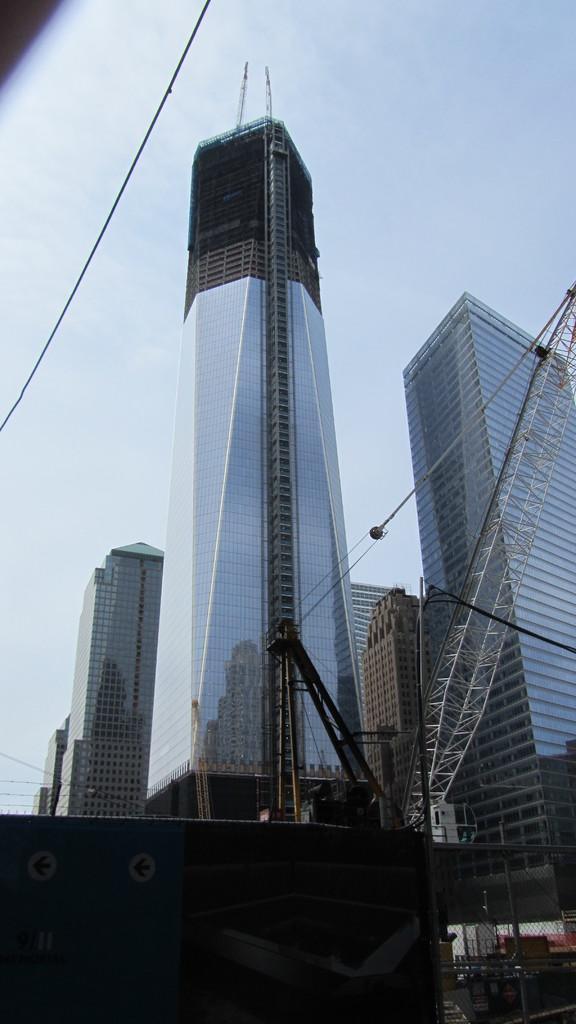Please provide a concise description of this image. In the foreground of this image, at the bottom, there is a shelter and fencing. In the middle, it seems like a crane. In the background, there are skyscrapers and the sky. 